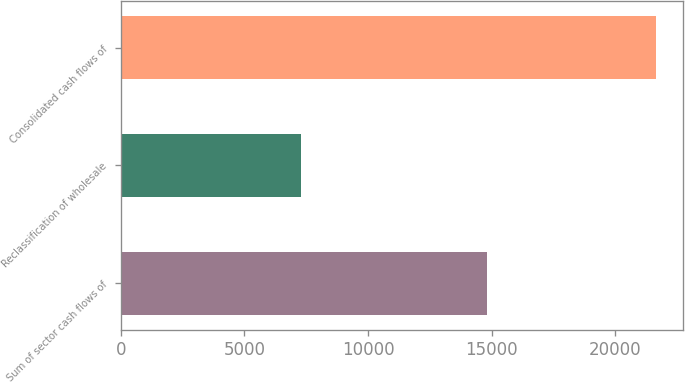<chart> <loc_0><loc_0><loc_500><loc_500><bar_chart><fcel>Sum of sector cash flows of<fcel>Reclassification of wholesale<fcel>Consolidated cash flows of<nl><fcel>14820<fcel>7290<fcel>21674<nl></chart> 